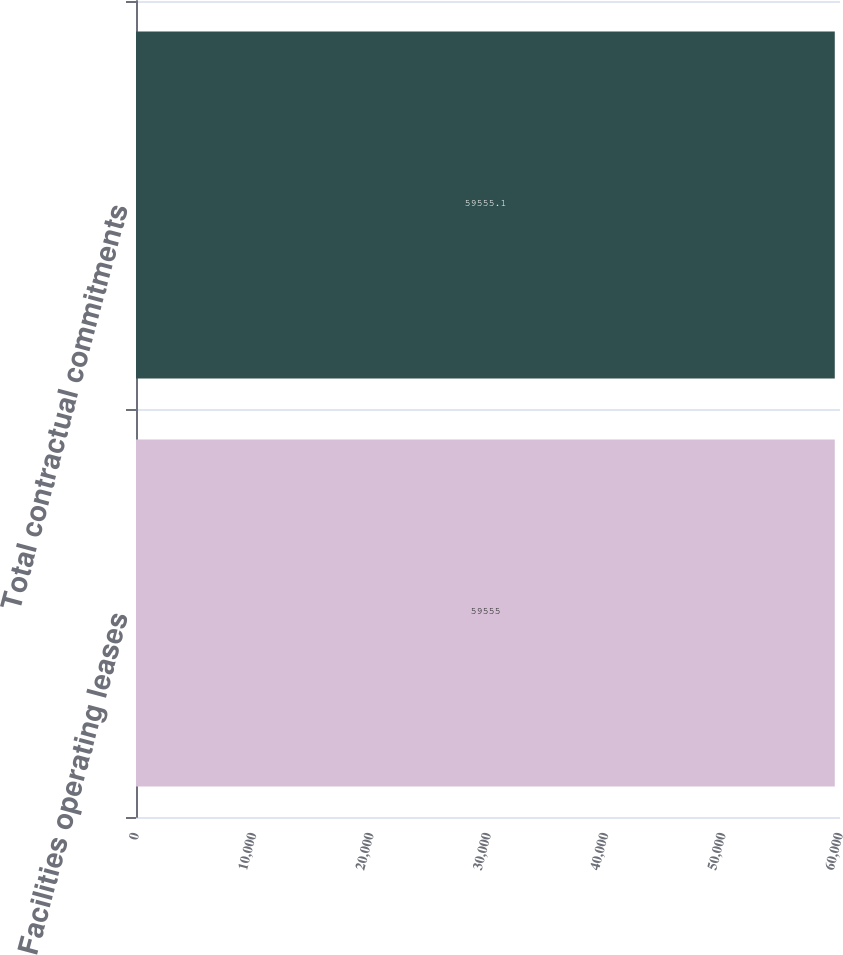<chart> <loc_0><loc_0><loc_500><loc_500><bar_chart><fcel>Facilities operating leases<fcel>Total contractual commitments<nl><fcel>59555<fcel>59555.1<nl></chart> 